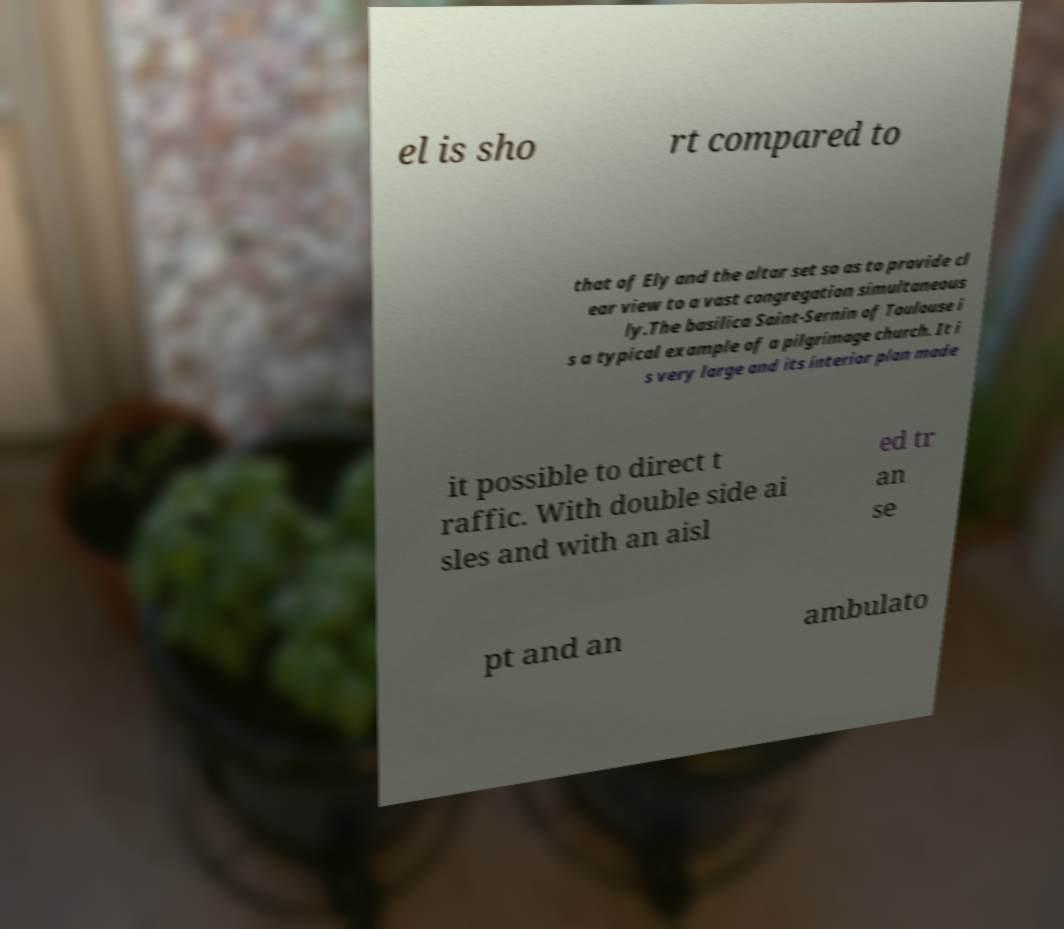There's text embedded in this image that I need extracted. Can you transcribe it verbatim? el is sho rt compared to that of Ely and the altar set so as to provide cl ear view to a vast congregation simultaneous ly.The basilica Saint-Sernin of Toulouse i s a typical example of a pilgrimage church. It i s very large and its interior plan made it possible to direct t raffic. With double side ai sles and with an aisl ed tr an se pt and an ambulato 